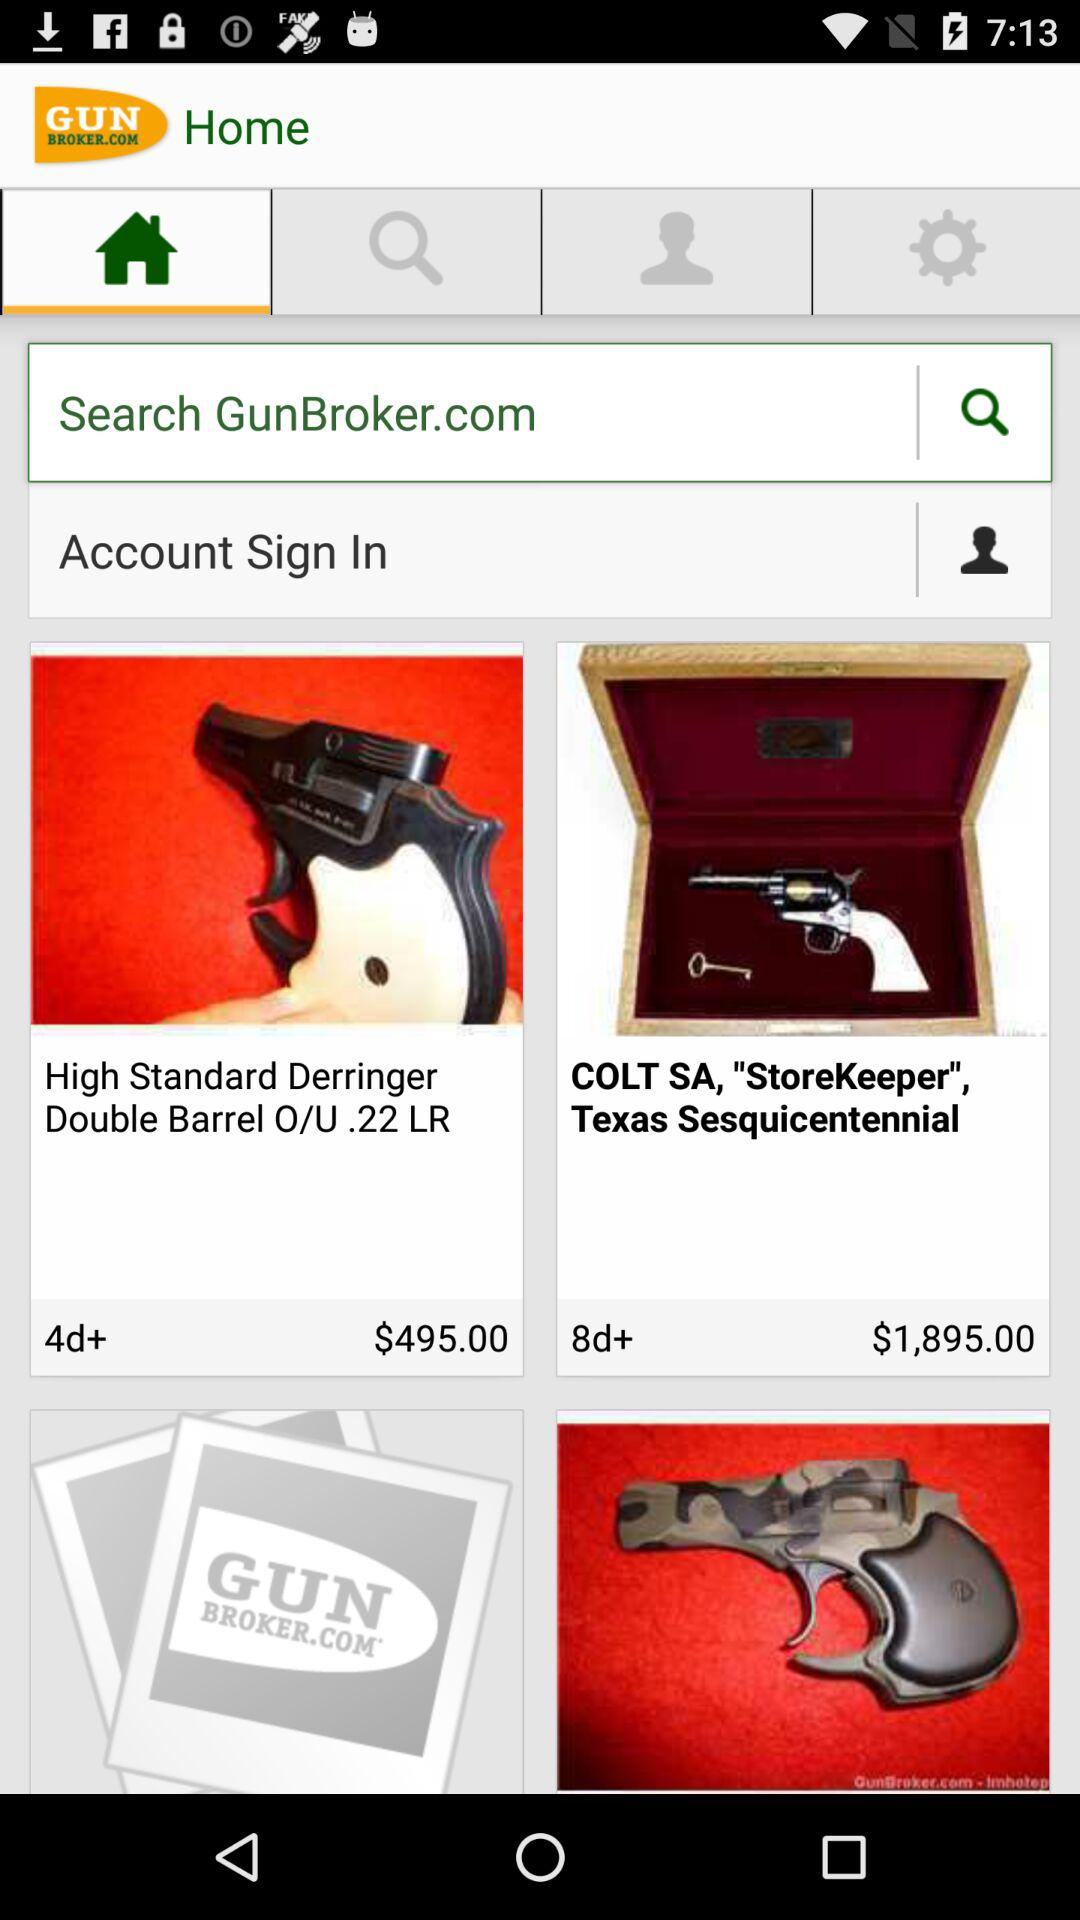What is the name of the application? The name of the application is "GunBroker.com". 